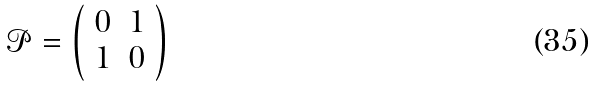Convert formula to latex. <formula><loc_0><loc_0><loc_500><loc_500>\mathcal { P } = \left ( \begin{array} { c c } { 0 } & { 1 } \\ { 1 } & { 0 } \end{array} \right )</formula> 